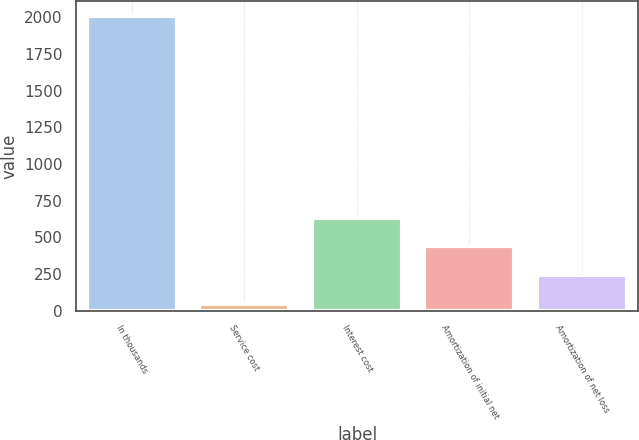<chart> <loc_0><loc_0><loc_500><loc_500><bar_chart><fcel>In thousands<fcel>Service cost<fcel>Interest cost<fcel>Amortization of initial net<fcel>Amortization of net loss<nl><fcel>2009<fcel>44<fcel>633.5<fcel>437<fcel>240.5<nl></chart> 